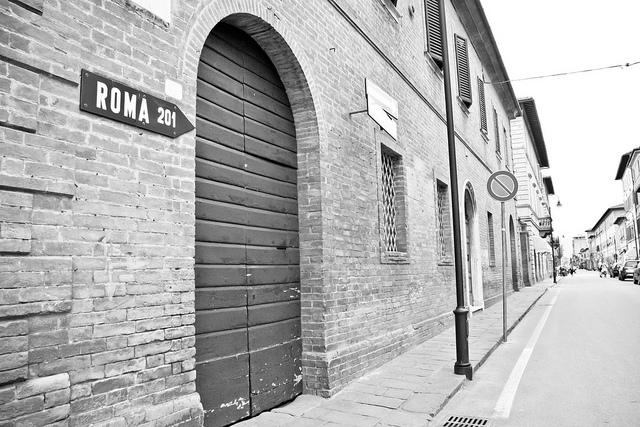What place is this most likely? italy 